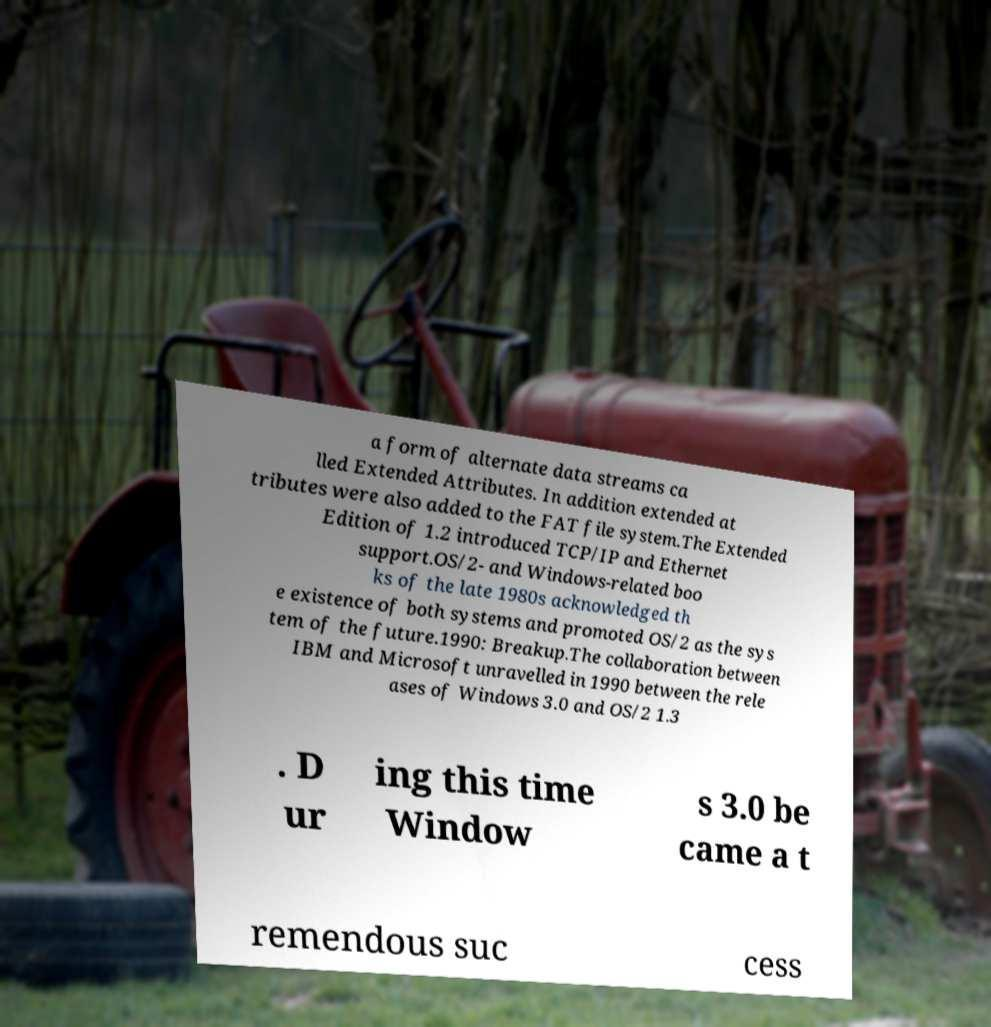I need the written content from this picture converted into text. Can you do that? a form of alternate data streams ca lled Extended Attributes. In addition extended at tributes were also added to the FAT file system.The Extended Edition of 1.2 introduced TCP/IP and Ethernet support.OS/2- and Windows-related boo ks of the late 1980s acknowledged th e existence of both systems and promoted OS/2 as the sys tem of the future.1990: Breakup.The collaboration between IBM and Microsoft unravelled in 1990 between the rele ases of Windows 3.0 and OS/2 1.3 . D ur ing this time Window s 3.0 be came a t remendous suc cess 